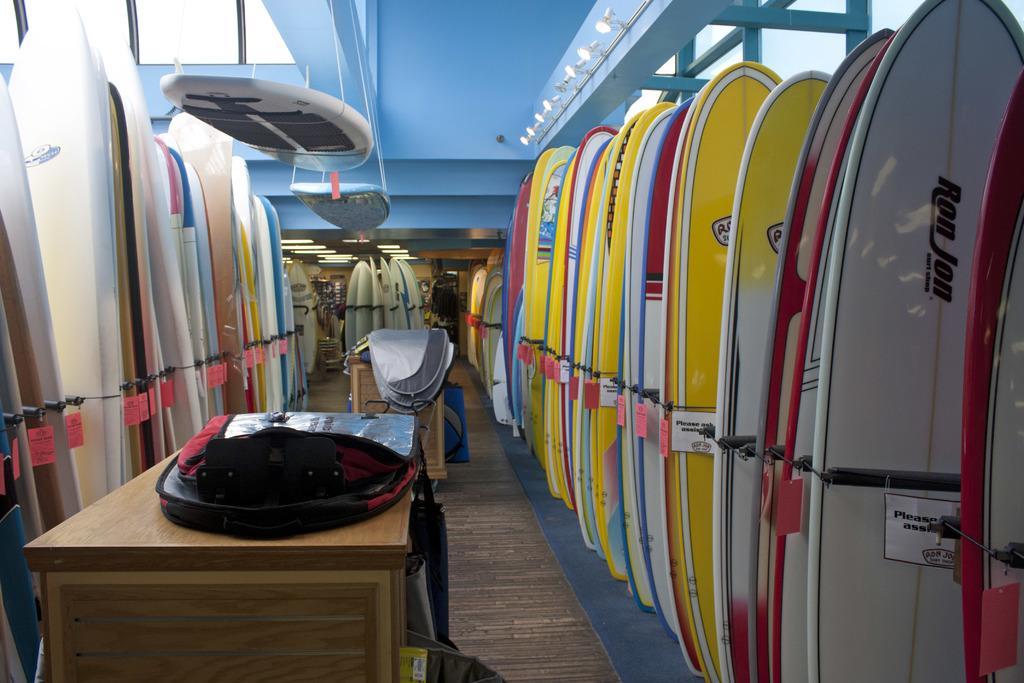How would you summarize this image in a sentence or two? In center of the image there is a table. At the right side of the image there are many surfing boards arranged in an order. At the left side of the image there are also surfing boards arranged in a order. At the background of the image there are surfing boards in the center. At the top the image is wall. 